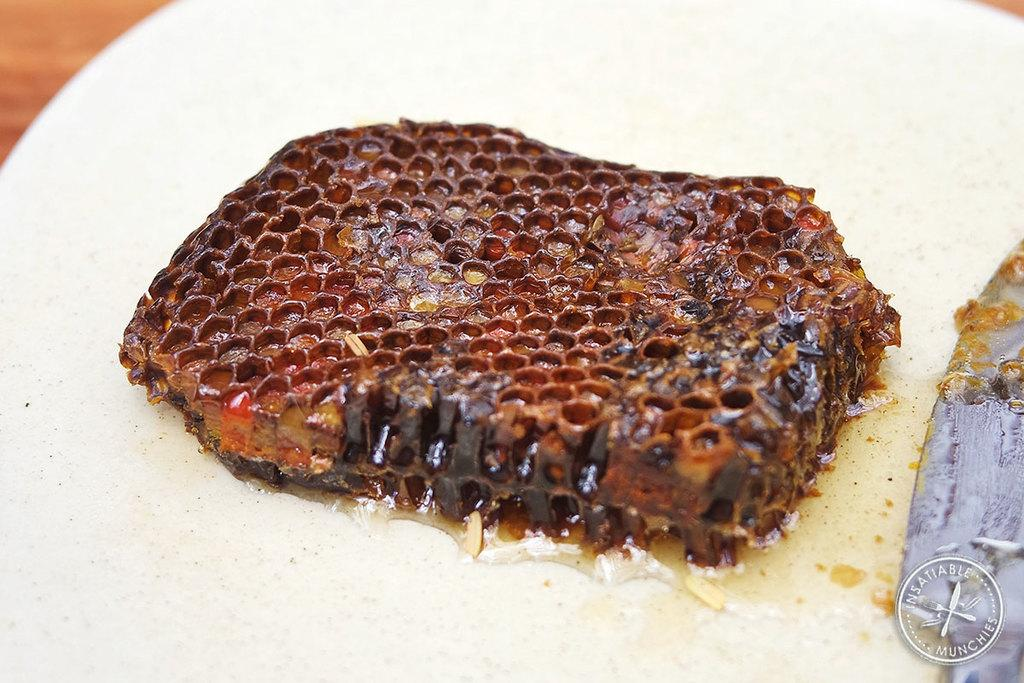What is the main subject of the image? The main subject of the image is a honeycomb. What colors can be seen on the honeycomb? The honeycomb has brown and black colors. What is the background or surface on which the honeycomb is placed? The honeycomb is on a white surface. How many buttons can be seen on the honeycomb in the image? There are no buttons present on the honeycomb in the image. What type of insects can be seen interacting with the honeycomb in the image? There are no insects, such as ants, visible in the image. 